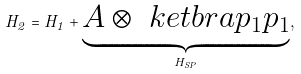<formula> <loc_0><loc_0><loc_500><loc_500>H _ { 2 } = H _ { 1 } + \underbrace { A \otimes \ k e t b r a { p _ { 1 } } { p _ { 1 } } } _ { H _ { S P } } ,</formula> 